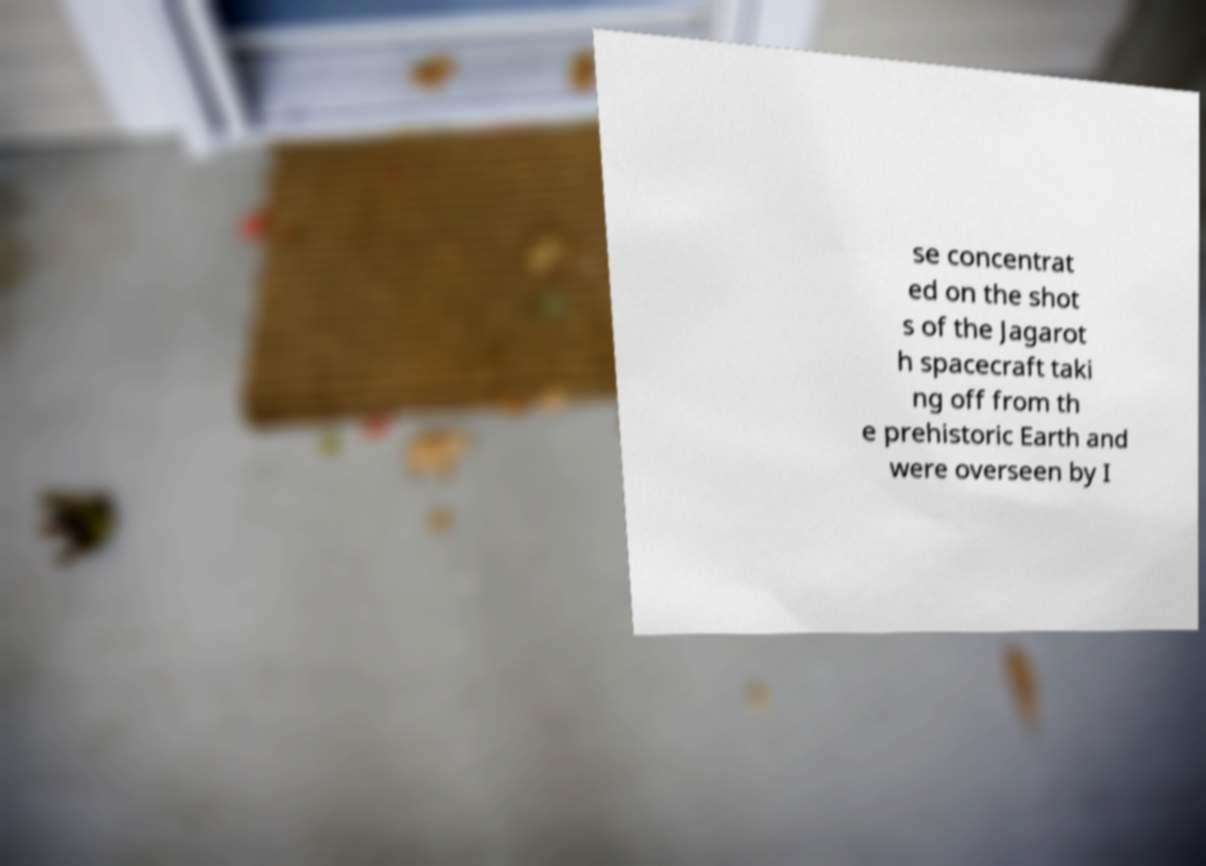Could you assist in decoding the text presented in this image and type it out clearly? se concentrat ed on the shot s of the Jagarot h spacecraft taki ng off from th e prehistoric Earth and were overseen by I 